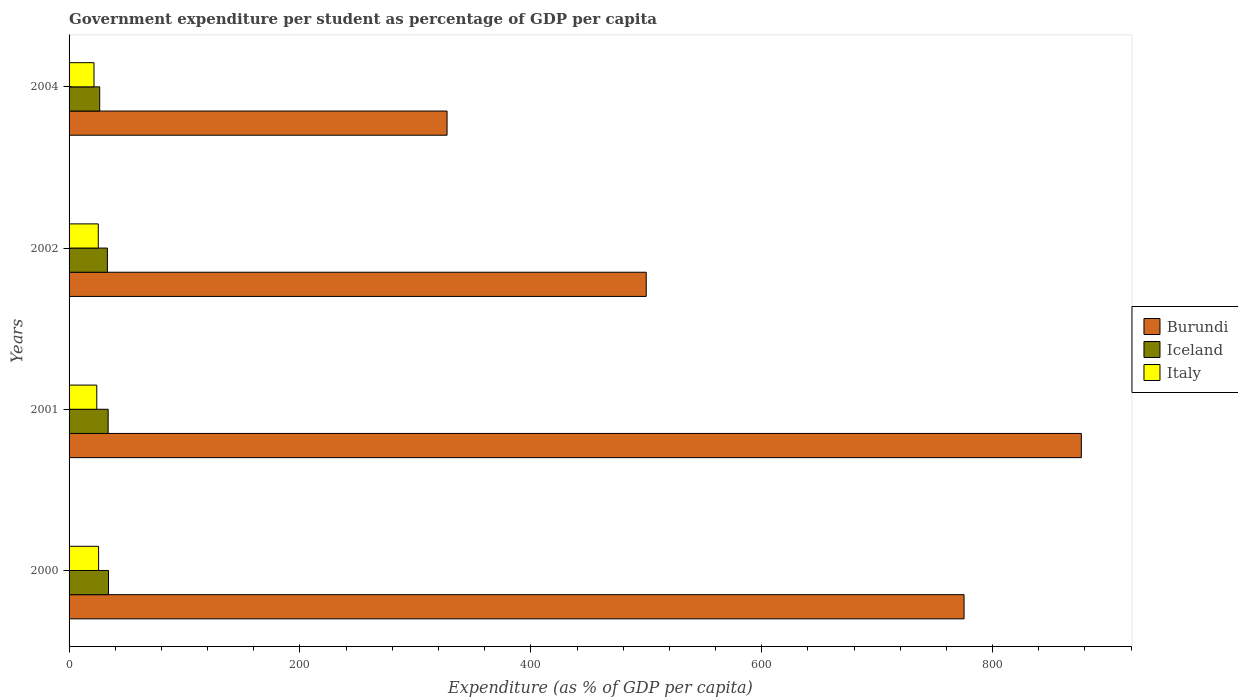How many groups of bars are there?
Provide a short and direct response. 4. Are the number of bars per tick equal to the number of legend labels?
Make the answer very short. Yes. How many bars are there on the 2nd tick from the top?
Give a very brief answer. 3. How many bars are there on the 3rd tick from the bottom?
Provide a succinct answer. 3. In how many cases, is the number of bars for a given year not equal to the number of legend labels?
Provide a succinct answer. 0. What is the percentage of expenditure per student in Iceland in 2000?
Your answer should be very brief. 34.14. Across all years, what is the maximum percentage of expenditure per student in Burundi?
Give a very brief answer. 876.87. Across all years, what is the minimum percentage of expenditure per student in Italy?
Your response must be concise. 21.59. What is the total percentage of expenditure per student in Italy in the graph?
Keep it short and to the point. 96.47. What is the difference between the percentage of expenditure per student in Burundi in 2002 and that in 2004?
Keep it short and to the point. 172.53. What is the difference between the percentage of expenditure per student in Iceland in 2001 and the percentage of expenditure per student in Burundi in 2002?
Your answer should be compact. -466.1. What is the average percentage of expenditure per student in Italy per year?
Your response must be concise. 24.12. In the year 2002, what is the difference between the percentage of expenditure per student in Italy and percentage of expenditure per student in Burundi?
Your answer should be compact. -474.65. What is the ratio of the percentage of expenditure per student in Italy in 2002 to that in 2004?
Keep it short and to the point. 1.17. Is the percentage of expenditure per student in Iceland in 2001 less than that in 2004?
Offer a very short reply. No. What is the difference between the highest and the second highest percentage of expenditure per student in Italy?
Your response must be concise. 0.27. What is the difference between the highest and the lowest percentage of expenditure per student in Italy?
Give a very brief answer. 3.98. What does the 3rd bar from the top in 2004 represents?
Give a very brief answer. Burundi. What does the 1st bar from the bottom in 2000 represents?
Keep it short and to the point. Burundi. What is the difference between two consecutive major ticks on the X-axis?
Your answer should be compact. 200. Are the values on the major ticks of X-axis written in scientific E-notation?
Provide a succinct answer. No. Does the graph contain any zero values?
Provide a short and direct response. No. Does the graph contain grids?
Make the answer very short. No. How many legend labels are there?
Your answer should be compact. 3. How are the legend labels stacked?
Your answer should be very brief. Vertical. What is the title of the graph?
Give a very brief answer. Government expenditure per student as percentage of GDP per capita. What is the label or title of the X-axis?
Make the answer very short. Expenditure (as % of GDP per capita). What is the label or title of the Y-axis?
Your answer should be very brief. Years. What is the Expenditure (as % of GDP per capita) of Burundi in 2000?
Offer a very short reply. 775.27. What is the Expenditure (as % of GDP per capita) of Iceland in 2000?
Give a very brief answer. 34.14. What is the Expenditure (as % of GDP per capita) of Italy in 2000?
Offer a very short reply. 25.57. What is the Expenditure (as % of GDP per capita) in Burundi in 2001?
Ensure brevity in your answer.  876.87. What is the Expenditure (as % of GDP per capita) of Iceland in 2001?
Your answer should be very brief. 33.86. What is the Expenditure (as % of GDP per capita) in Italy in 2001?
Give a very brief answer. 24. What is the Expenditure (as % of GDP per capita) of Burundi in 2002?
Your response must be concise. 499.95. What is the Expenditure (as % of GDP per capita) of Iceland in 2002?
Keep it short and to the point. 33.2. What is the Expenditure (as % of GDP per capita) of Italy in 2002?
Keep it short and to the point. 25.31. What is the Expenditure (as % of GDP per capita) of Burundi in 2004?
Make the answer very short. 327.42. What is the Expenditure (as % of GDP per capita) of Iceland in 2004?
Your response must be concise. 26.53. What is the Expenditure (as % of GDP per capita) of Italy in 2004?
Your answer should be compact. 21.59. Across all years, what is the maximum Expenditure (as % of GDP per capita) in Burundi?
Your response must be concise. 876.87. Across all years, what is the maximum Expenditure (as % of GDP per capita) in Iceland?
Your answer should be compact. 34.14. Across all years, what is the maximum Expenditure (as % of GDP per capita) in Italy?
Your answer should be compact. 25.57. Across all years, what is the minimum Expenditure (as % of GDP per capita) in Burundi?
Keep it short and to the point. 327.42. Across all years, what is the minimum Expenditure (as % of GDP per capita) of Iceland?
Your response must be concise. 26.53. Across all years, what is the minimum Expenditure (as % of GDP per capita) of Italy?
Ensure brevity in your answer.  21.59. What is the total Expenditure (as % of GDP per capita) of Burundi in the graph?
Ensure brevity in your answer.  2479.52. What is the total Expenditure (as % of GDP per capita) in Iceland in the graph?
Your response must be concise. 127.73. What is the total Expenditure (as % of GDP per capita) of Italy in the graph?
Offer a very short reply. 96.47. What is the difference between the Expenditure (as % of GDP per capita) in Burundi in 2000 and that in 2001?
Offer a terse response. -101.6. What is the difference between the Expenditure (as % of GDP per capita) in Iceland in 2000 and that in 2001?
Offer a very short reply. 0.28. What is the difference between the Expenditure (as % of GDP per capita) in Italy in 2000 and that in 2001?
Offer a terse response. 1.58. What is the difference between the Expenditure (as % of GDP per capita) of Burundi in 2000 and that in 2002?
Ensure brevity in your answer.  275.32. What is the difference between the Expenditure (as % of GDP per capita) in Iceland in 2000 and that in 2002?
Provide a succinct answer. 0.93. What is the difference between the Expenditure (as % of GDP per capita) in Italy in 2000 and that in 2002?
Provide a short and direct response. 0.27. What is the difference between the Expenditure (as % of GDP per capita) of Burundi in 2000 and that in 2004?
Provide a succinct answer. 447.85. What is the difference between the Expenditure (as % of GDP per capita) in Iceland in 2000 and that in 2004?
Keep it short and to the point. 7.6. What is the difference between the Expenditure (as % of GDP per capita) in Italy in 2000 and that in 2004?
Give a very brief answer. 3.98. What is the difference between the Expenditure (as % of GDP per capita) in Burundi in 2001 and that in 2002?
Offer a terse response. 376.92. What is the difference between the Expenditure (as % of GDP per capita) in Iceland in 2001 and that in 2002?
Your answer should be very brief. 0.65. What is the difference between the Expenditure (as % of GDP per capita) in Italy in 2001 and that in 2002?
Offer a very short reply. -1.31. What is the difference between the Expenditure (as % of GDP per capita) in Burundi in 2001 and that in 2004?
Make the answer very short. 549.45. What is the difference between the Expenditure (as % of GDP per capita) in Iceland in 2001 and that in 2004?
Ensure brevity in your answer.  7.33. What is the difference between the Expenditure (as % of GDP per capita) of Italy in 2001 and that in 2004?
Your answer should be very brief. 2.41. What is the difference between the Expenditure (as % of GDP per capita) in Burundi in 2002 and that in 2004?
Make the answer very short. 172.53. What is the difference between the Expenditure (as % of GDP per capita) of Iceland in 2002 and that in 2004?
Provide a short and direct response. 6.67. What is the difference between the Expenditure (as % of GDP per capita) in Italy in 2002 and that in 2004?
Provide a succinct answer. 3.72. What is the difference between the Expenditure (as % of GDP per capita) of Burundi in 2000 and the Expenditure (as % of GDP per capita) of Iceland in 2001?
Make the answer very short. 741.42. What is the difference between the Expenditure (as % of GDP per capita) in Burundi in 2000 and the Expenditure (as % of GDP per capita) in Italy in 2001?
Offer a terse response. 751.28. What is the difference between the Expenditure (as % of GDP per capita) in Iceland in 2000 and the Expenditure (as % of GDP per capita) in Italy in 2001?
Offer a terse response. 10.14. What is the difference between the Expenditure (as % of GDP per capita) in Burundi in 2000 and the Expenditure (as % of GDP per capita) in Iceland in 2002?
Offer a terse response. 742.07. What is the difference between the Expenditure (as % of GDP per capita) in Burundi in 2000 and the Expenditure (as % of GDP per capita) in Italy in 2002?
Offer a very short reply. 749.97. What is the difference between the Expenditure (as % of GDP per capita) of Iceland in 2000 and the Expenditure (as % of GDP per capita) of Italy in 2002?
Provide a short and direct response. 8.83. What is the difference between the Expenditure (as % of GDP per capita) in Burundi in 2000 and the Expenditure (as % of GDP per capita) in Iceland in 2004?
Give a very brief answer. 748.74. What is the difference between the Expenditure (as % of GDP per capita) of Burundi in 2000 and the Expenditure (as % of GDP per capita) of Italy in 2004?
Make the answer very short. 753.68. What is the difference between the Expenditure (as % of GDP per capita) of Iceland in 2000 and the Expenditure (as % of GDP per capita) of Italy in 2004?
Make the answer very short. 12.55. What is the difference between the Expenditure (as % of GDP per capita) of Burundi in 2001 and the Expenditure (as % of GDP per capita) of Iceland in 2002?
Provide a succinct answer. 843.67. What is the difference between the Expenditure (as % of GDP per capita) of Burundi in 2001 and the Expenditure (as % of GDP per capita) of Italy in 2002?
Keep it short and to the point. 851.56. What is the difference between the Expenditure (as % of GDP per capita) in Iceland in 2001 and the Expenditure (as % of GDP per capita) in Italy in 2002?
Your response must be concise. 8.55. What is the difference between the Expenditure (as % of GDP per capita) in Burundi in 2001 and the Expenditure (as % of GDP per capita) in Iceland in 2004?
Make the answer very short. 850.34. What is the difference between the Expenditure (as % of GDP per capita) in Burundi in 2001 and the Expenditure (as % of GDP per capita) in Italy in 2004?
Your answer should be very brief. 855.28. What is the difference between the Expenditure (as % of GDP per capita) of Iceland in 2001 and the Expenditure (as % of GDP per capita) of Italy in 2004?
Offer a terse response. 12.27. What is the difference between the Expenditure (as % of GDP per capita) in Burundi in 2002 and the Expenditure (as % of GDP per capita) in Iceland in 2004?
Your answer should be very brief. 473.42. What is the difference between the Expenditure (as % of GDP per capita) in Burundi in 2002 and the Expenditure (as % of GDP per capita) in Italy in 2004?
Make the answer very short. 478.36. What is the difference between the Expenditure (as % of GDP per capita) of Iceland in 2002 and the Expenditure (as % of GDP per capita) of Italy in 2004?
Keep it short and to the point. 11.61. What is the average Expenditure (as % of GDP per capita) in Burundi per year?
Ensure brevity in your answer.  619.88. What is the average Expenditure (as % of GDP per capita) of Iceland per year?
Offer a very short reply. 31.93. What is the average Expenditure (as % of GDP per capita) in Italy per year?
Make the answer very short. 24.12. In the year 2000, what is the difference between the Expenditure (as % of GDP per capita) in Burundi and Expenditure (as % of GDP per capita) in Iceland?
Offer a very short reply. 741.14. In the year 2000, what is the difference between the Expenditure (as % of GDP per capita) of Burundi and Expenditure (as % of GDP per capita) of Italy?
Your answer should be compact. 749.7. In the year 2000, what is the difference between the Expenditure (as % of GDP per capita) of Iceland and Expenditure (as % of GDP per capita) of Italy?
Provide a succinct answer. 8.56. In the year 2001, what is the difference between the Expenditure (as % of GDP per capita) in Burundi and Expenditure (as % of GDP per capita) in Iceland?
Keep it short and to the point. 843.01. In the year 2001, what is the difference between the Expenditure (as % of GDP per capita) of Burundi and Expenditure (as % of GDP per capita) of Italy?
Provide a short and direct response. 852.87. In the year 2001, what is the difference between the Expenditure (as % of GDP per capita) in Iceland and Expenditure (as % of GDP per capita) in Italy?
Your answer should be very brief. 9.86. In the year 2002, what is the difference between the Expenditure (as % of GDP per capita) of Burundi and Expenditure (as % of GDP per capita) of Iceland?
Make the answer very short. 466.75. In the year 2002, what is the difference between the Expenditure (as % of GDP per capita) of Burundi and Expenditure (as % of GDP per capita) of Italy?
Provide a succinct answer. 474.65. In the year 2002, what is the difference between the Expenditure (as % of GDP per capita) in Iceland and Expenditure (as % of GDP per capita) in Italy?
Your answer should be compact. 7.9. In the year 2004, what is the difference between the Expenditure (as % of GDP per capita) of Burundi and Expenditure (as % of GDP per capita) of Iceland?
Your answer should be very brief. 300.89. In the year 2004, what is the difference between the Expenditure (as % of GDP per capita) of Burundi and Expenditure (as % of GDP per capita) of Italy?
Offer a very short reply. 305.83. In the year 2004, what is the difference between the Expenditure (as % of GDP per capita) in Iceland and Expenditure (as % of GDP per capita) in Italy?
Provide a short and direct response. 4.94. What is the ratio of the Expenditure (as % of GDP per capita) in Burundi in 2000 to that in 2001?
Offer a terse response. 0.88. What is the ratio of the Expenditure (as % of GDP per capita) of Iceland in 2000 to that in 2001?
Offer a very short reply. 1.01. What is the ratio of the Expenditure (as % of GDP per capita) of Italy in 2000 to that in 2001?
Make the answer very short. 1.07. What is the ratio of the Expenditure (as % of GDP per capita) of Burundi in 2000 to that in 2002?
Keep it short and to the point. 1.55. What is the ratio of the Expenditure (as % of GDP per capita) of Iceland in 2000 to that in 2002?
Your answer should be very brief. 1.03. What is the ratio of the Expenditure (as % of GDP per capita) in Italy in 2000 to that in 2002?
Your response must be concise. 1.01. What is the ratio of the Expenditure (as % of GDP per capita) of Burundi in 2000 to that in 2004?
Offer a very short reply. 2.37. What is the ratio of the Expenditure (as % of GDP per capita) in Iceland in 2000 to that in 2004?
Your answer should be compact. 1.29. What is the ratio of the Expenditure (as % of GDP per capita) of Italy in 2000 to that in 2004?
Make the answer very short. 1.18. What is the ratio of the Expenditure (as % of GDP per capita) of Burundi in 2001 to that in 2002?
Your response must be concise. 1.75. What is the ratio of the Expenditure (as % of GDP per capita) in Iceland in 2001 to that in 2002?
Offer a terse response. 1.02. What is the ratio of the Expenditure (as % of GDP per capita) in Italy in 2001 to that in 2002?
Your response must be concise. 0.95. What is the ratio of the Expenditure (as % of GDP per capita) of Burundi in 2001 to that in 2004?
Offer a very short reply. 2.68. What is the ratio of the Expenditure (as % of GDP per capita) in Iceland in 2001 to that in 2004?
Your answer should be very brief. 1.28. What is the ratio of the Expenditure (as % of GDP per capita) in Italy in 2001 to that in 2004?
Your answer should be very brief. 1.11. What is the ratio of the Expenditure (as % of GDP per capita) of Burundi in 2002 to that in 2004?
Your answer should be compact. 1.53. What is the ratio of the Expenditure (as % of GDP per capita) of Iceland in 2002 to that in 2004?
Offer a very short reply. 1.25. What is the ratio of the Expenditure (as % of GDP per capita) of Italy in 2002 to that in 2004?
Your response must be concise. 1.17. What is the difference between the highest and the second highest Expenditure (as % of GDP per capita) in Burundi?
Your response must be concise. 101.6. What is the difference between the highest and the second highest Expenditure (as % of GDP per capita) in Iceland?
Your response must be concise. 0.28. What is the difference between the highest and the second highest Expenditure (as % of GDP per capita) in Italy?
Your answer should be compact. 0.27. What is the difference between the highest and the lowest Expenditure (as % of GDP per capita) of Burundi?
Keep it short and to the point. 549.45. What is the difference between the highest and the lowest Expenditure (as % of GDP per capita) of Iceland?
Offer a terse response. 7.6. What is the difference between the highest and the lowest Expenditure (as % of GDP per capita) in Italy?
Ensure brevity in your answer.  3.98. 